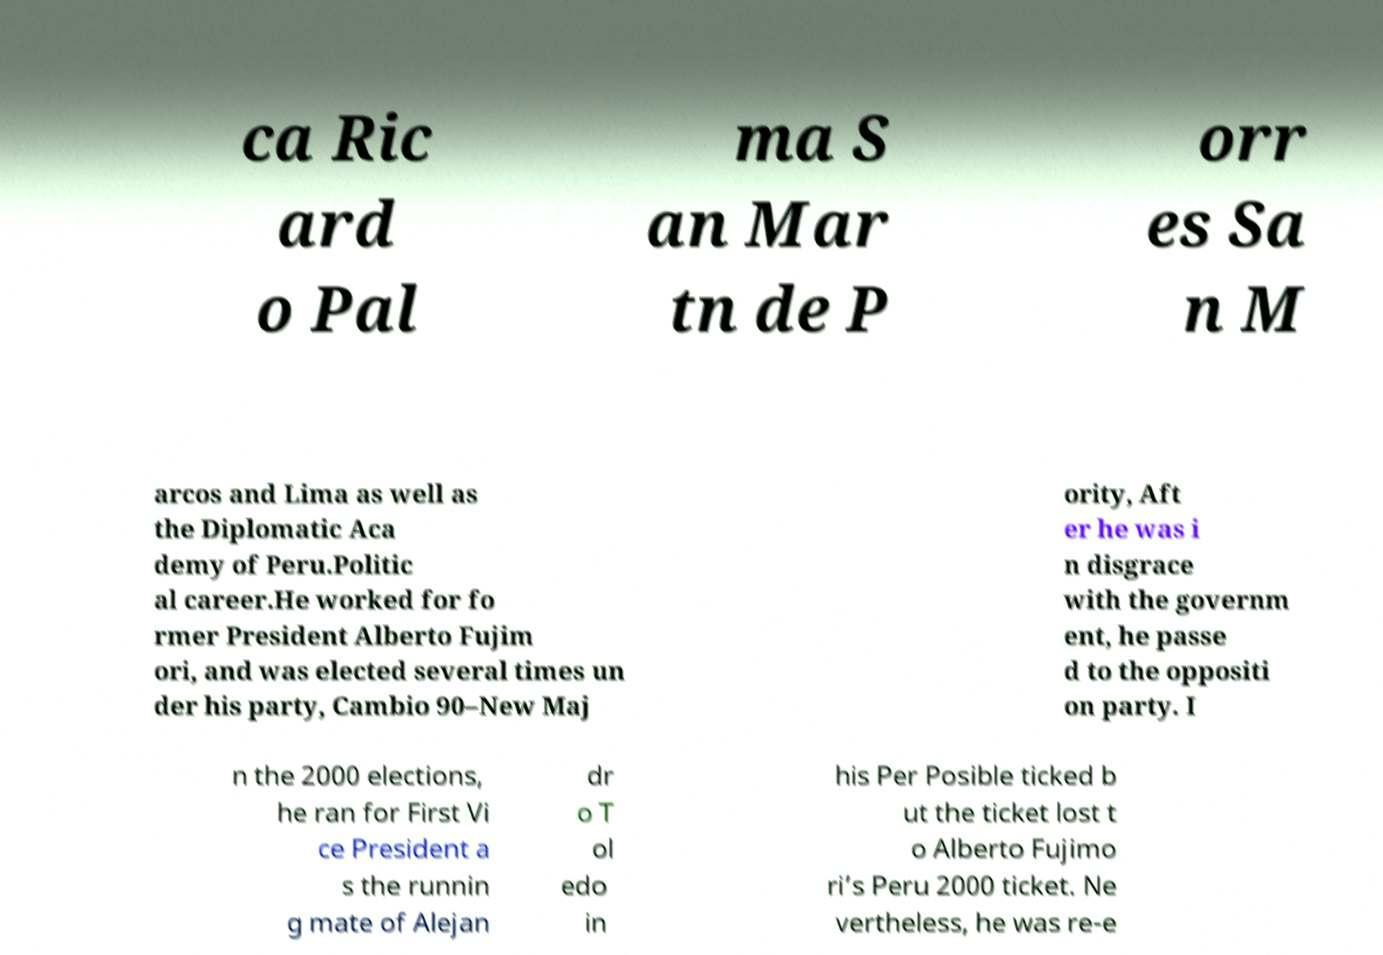Could you assist in decoding the text presented in this image and type it out clearly? ca Ric ard o Pal ma S an Mar tn de P orr es Sa n M arcos and Lima as well as the Diplomatic Aca demy of Peru.Politic al career.He worked for fo rmer President Alberto Fujim ori, and was elected several times un der his party, Cambio 90–New Maj ority, Aft er he was i n disgrace with the governm ent, he passe d to the oppositi on party. I n the 2000 elections, he ran for First Vi ce President a s the runnin g mate of Alejan dr o T ol edo in his Per Posible ticked b ut the ticket lost t o Alberto Fujimo ri’s Peru 2000 ticket. Ne vertheless, he was re-e 